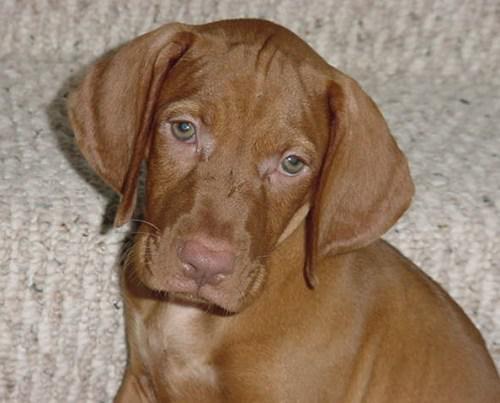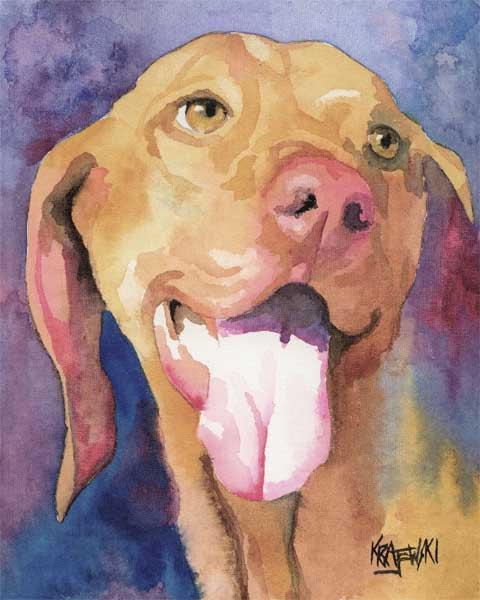The first image is the image on the left, the second image is the image on the right. Assess this claim about the two images: "The dog in the image on the left is lying down on a blue material.". Correct or not? Answer yes or no. No. 